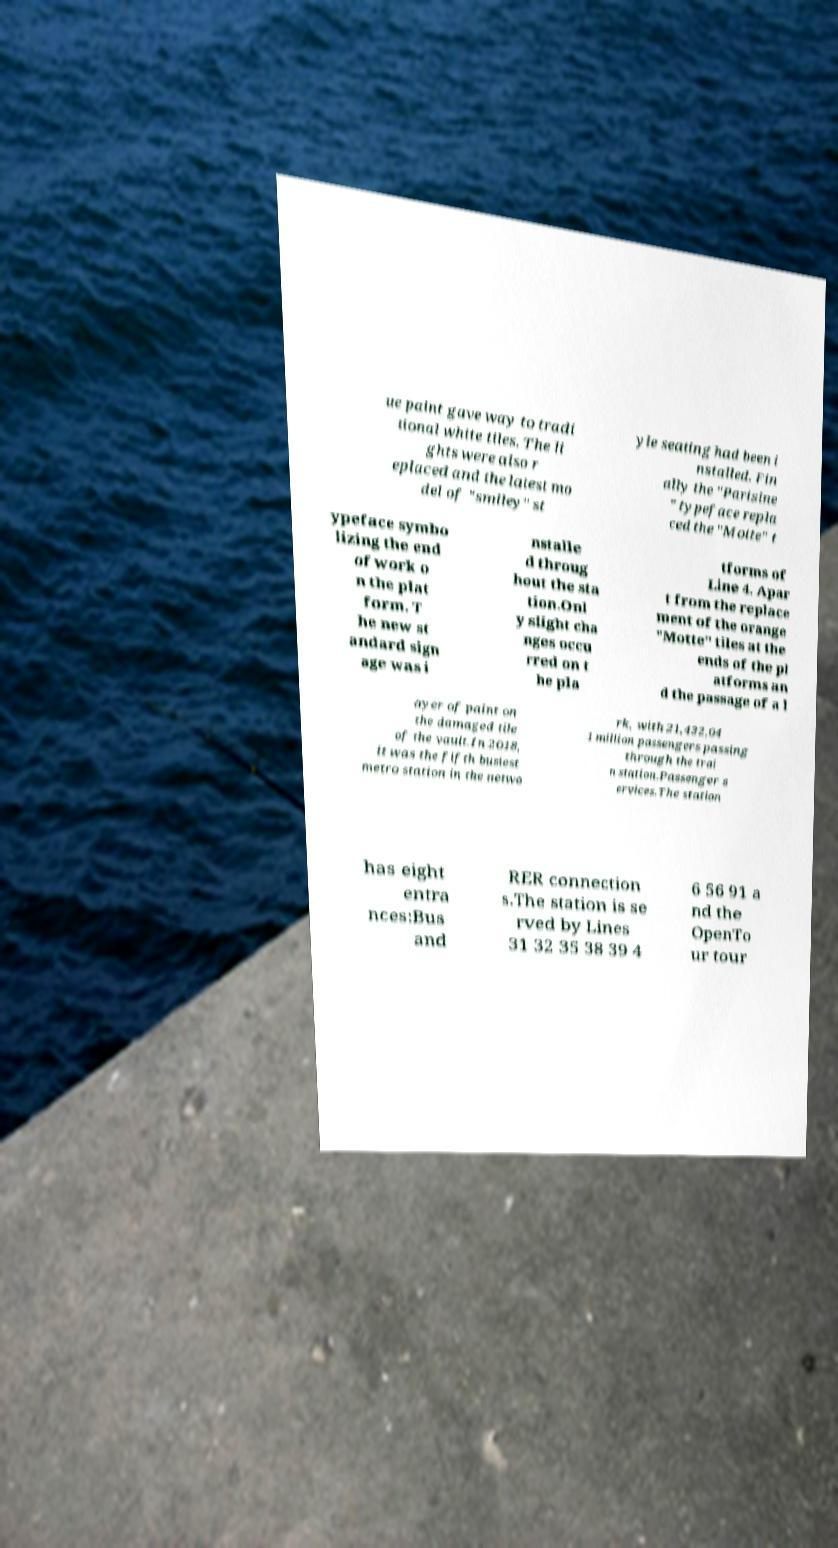Could you assist in decoding the text presented in this image and type it out clearly? ue paint gave way to tradi tional white tiles. The li ghts were also r eplaced and the latest mo del of "smiley" st yle seating had been i nstalled. Fin ally the "Parisine " typeface repla ced the "Motte" t ypeface symbo lizing the end of work o n the plat form. T he new st andard sign age was i nstalle d throug hout the sta tion.Onl y slight cha nges occu rred on t he pla tforms of Line 4. Apar t from the replace ment of the orange "Motte" tiles at the ends of the pl atforms an d the passage of a l ayer of paint on the damaged tile of the vault.In 2018, it was the fifth busiest metro station in the netwo rk, with 21,432,04 1 million passengers passing through the trai n station.Passenger s ervices.The station has eight entra nces:Bus and RER connection s.The station is se rved by Lines 31 32 35 38 39 4 6 56 91 a nd the OpenTo ur tour 